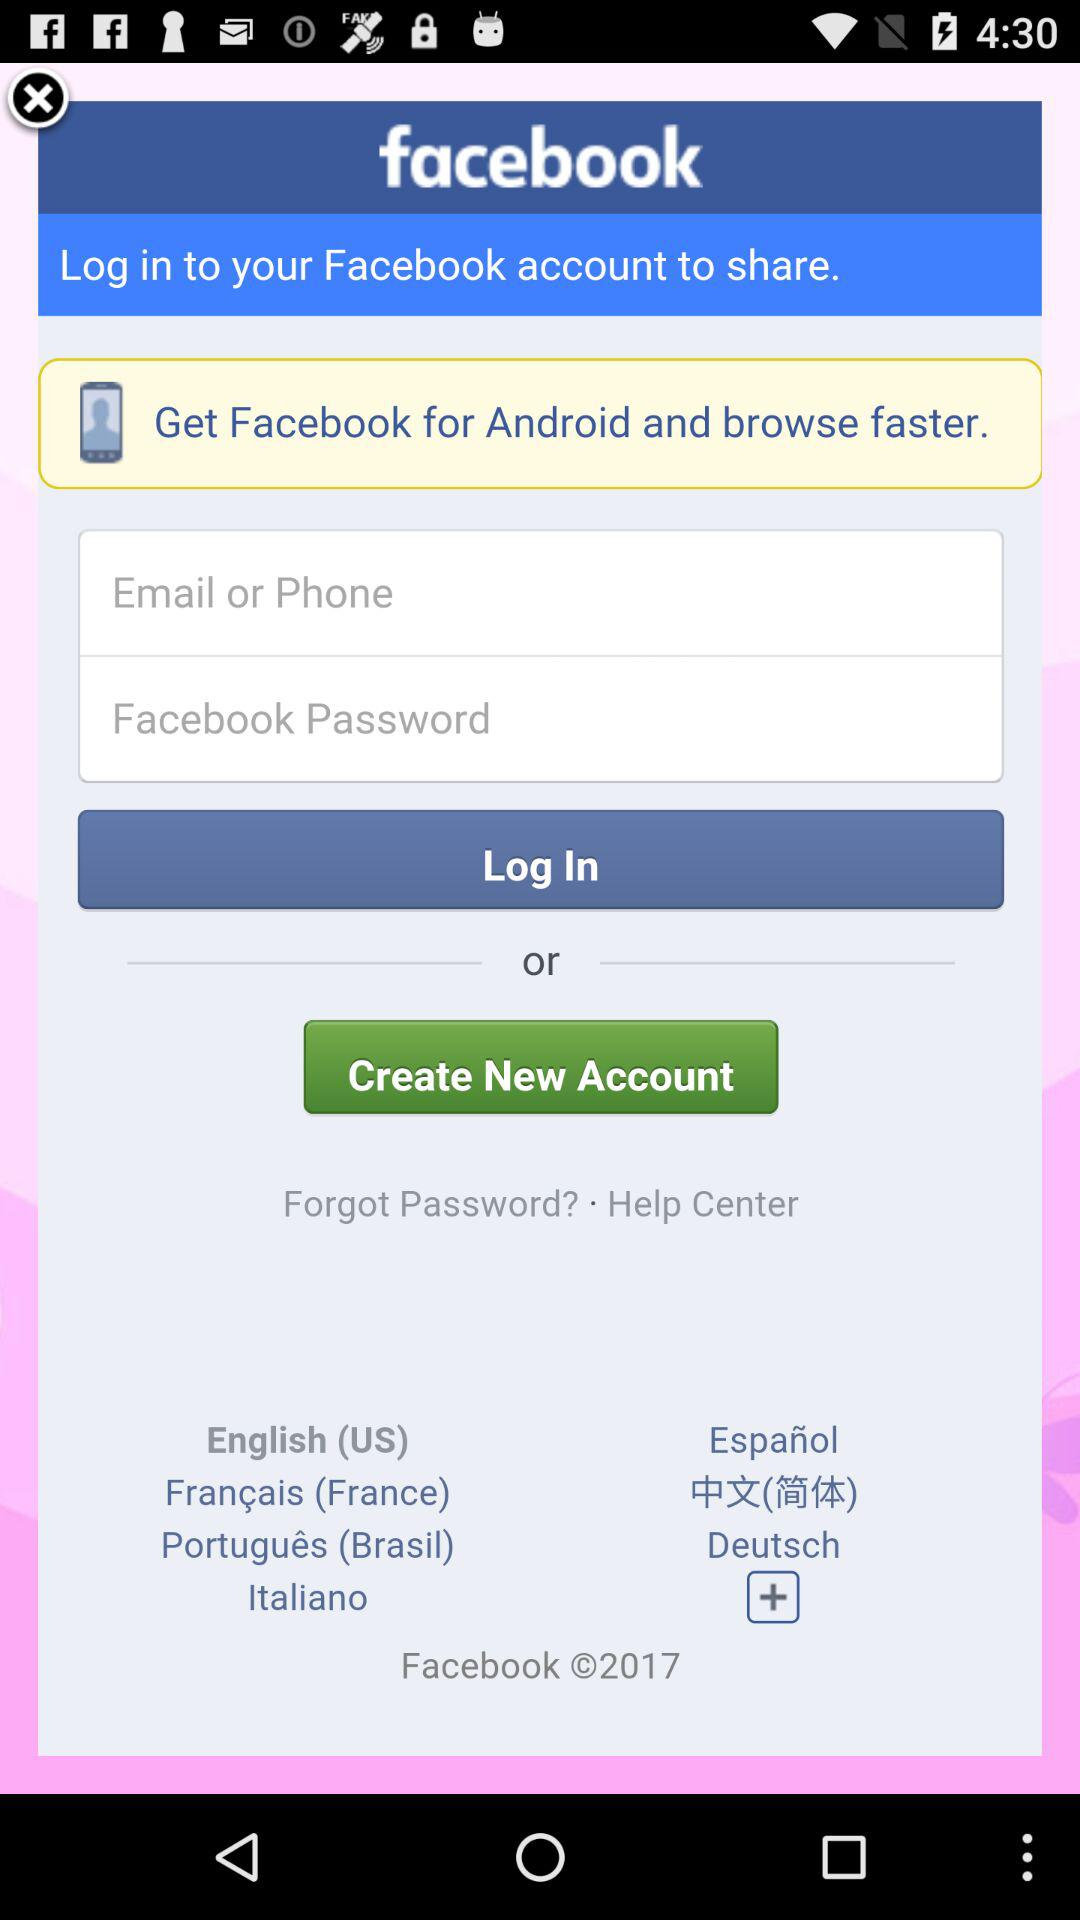What is the application name? The application name is "Facebook". 